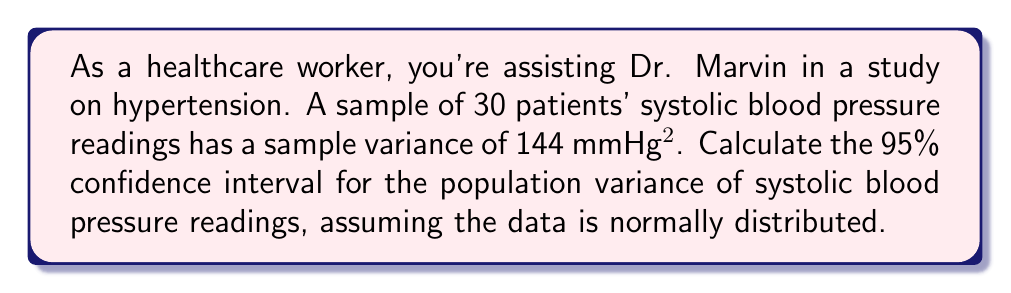Teach me how to tackle this problem. To calculate the confidence interval for the population variance, we'll use the chi-square distribution. The steps are as follows:

1) For a 95% confidence interval, we need the critical values of the chi-square distribution with n-1 degrees of freedom at α/2 and 1-α/2.

   df = n - 1 = 30 - 1 = 29
   α = 1 - 0.95 = 0.05
   
   Lower critical value: $\chi^2_{0.025,29} = 16.047$
   Upper critical value: $\chi^2_{0.975,29} = 45.722$

2) The formula for the confidence interval of the population variance is:

   $$\left[\frac{(n-1)s^2}{\chi^2_{1-\alpha/2,n-1}}, \frac{(n-1)s^2}{\chi^2_{\alpha/2,n-1}}\right]$$

   where $s^2$ is the sample variance.

3) Substituting our values:

   Lower bound: $\frac{(30-1)(144)}{45.722} = 91.16$
   Upper bound: $\frac{(30-1)(144)}{16.047} = 259.80$

4) Therefore, the 95% confidence interval for the population variance is (91.16, 259.80) mmHg².

5) To get the confidence interval for the population standard deviation, we take the square root of these values:

   $\sqrt{91.16} = 9.55$ mmHg
   $\sqrt{259.80} = 16.12$ mmHg
Answer: (91.16, 259.80) mmHg² for variance; (9.55, 16.12) mmHg for standard deviation 